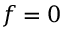Convert formula to latex. <formula><loc_0><loc_0><loc_500><loc_500>f = 0</formula> 